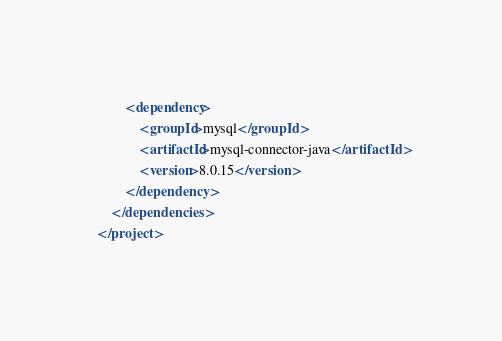Convert code to text. <code><loc_0><loc_0><loc_500><loc_500><_XML_>        <dependency>
            <groupId>mysql</groupId>
            <artifactId>mysql-connector-java</artifactId>
            <version>8.0.15</version>
        </dependency>
    </dependencies>
</project>
</code> 